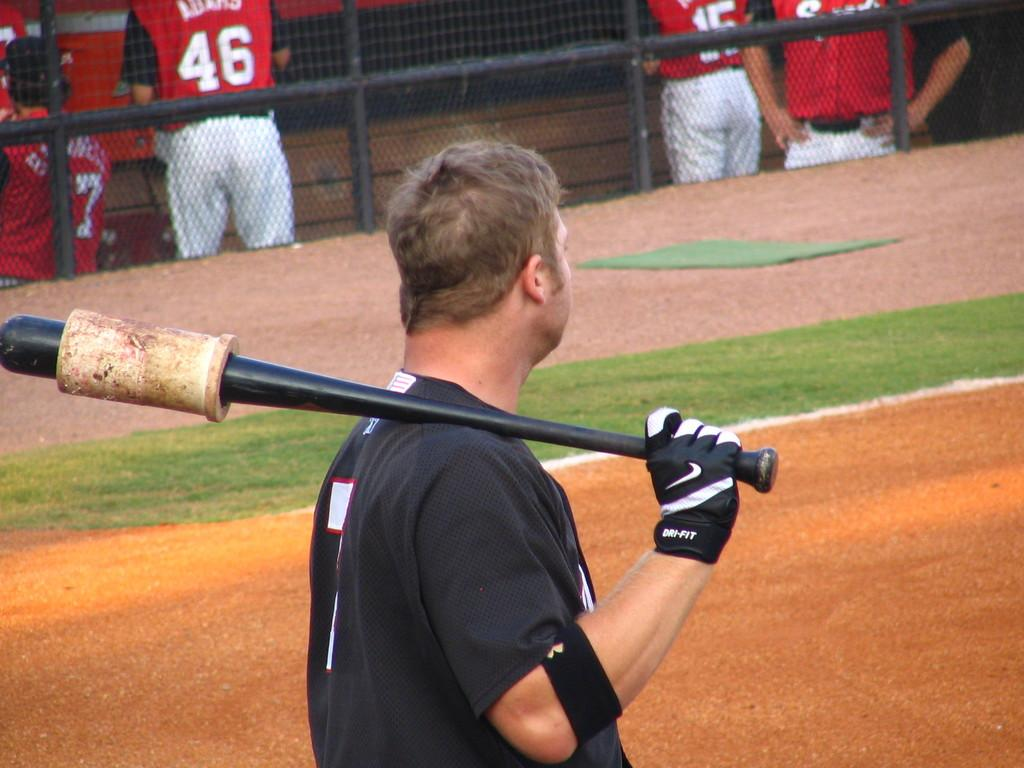What is the person in the image holding? The person in the image is holding a bat. What type of surface is visible in the image? There is grass on the land in the image. What can be seen at the top of the image? There is a fence at the top of the image. What are the people behind the fence doing? There are people standing behind the fence in the image. Can you see a girl holding a pin in the image? There is no girl or pin present in the image. 